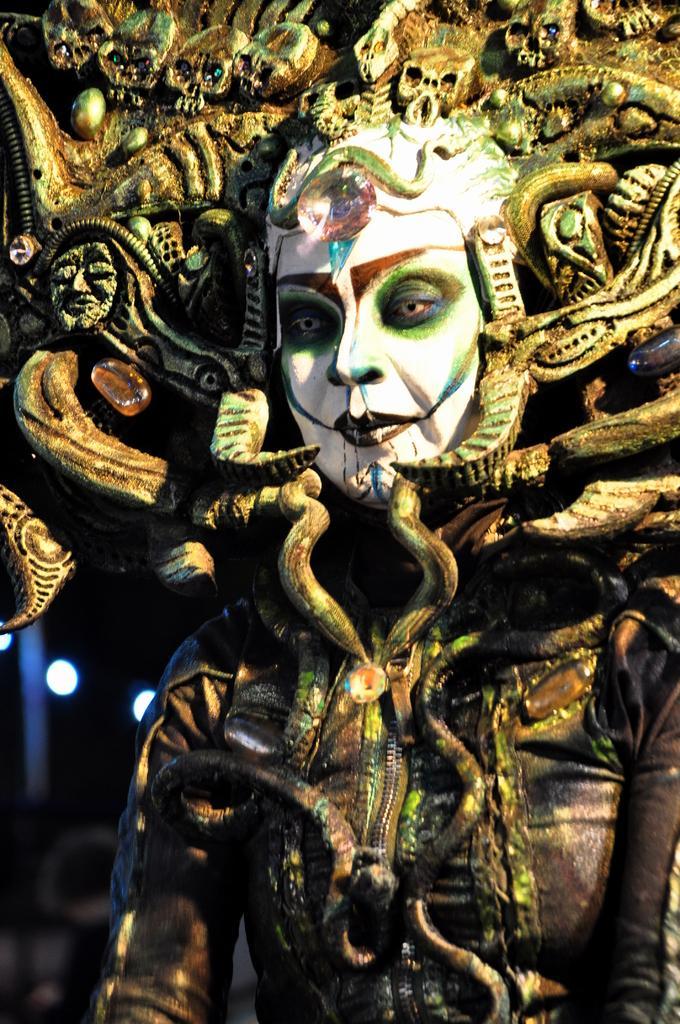Describe this image in one or two sentences. In this image in the front there is a person wearing a costume and the background is blurry. 